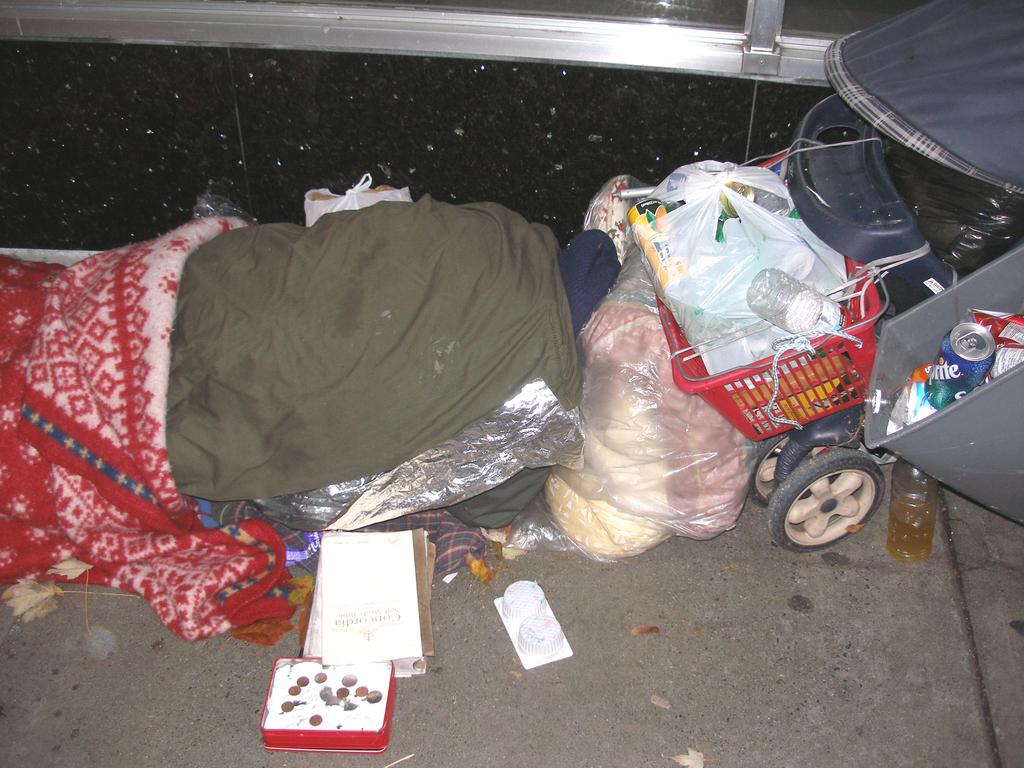What type of object is present in the image for carrying items? There is a shopping cart in the image for carrying items. What is the small container in the image? There is a can in the image. What is the large container in the image? There is a box in the image. What type of items can be seen in the image that are related to writing or reading? There are papers in the image. What type of items can be seen in the image that are wrapped in a cover? There are other things wrapped in a cover in the image. What type of items can be seen in the image that are related to clothing? There are clothes in the image. What type of surface is visible in the image that people might walk on? There is a footpath in the image. What type of structure is visible in the image that might separate different areas? There is a wall in the image. What type of food is being prepared in the image? There is no food present in the image. What type of beast can be seen in the image? There is no beast present in the image. 